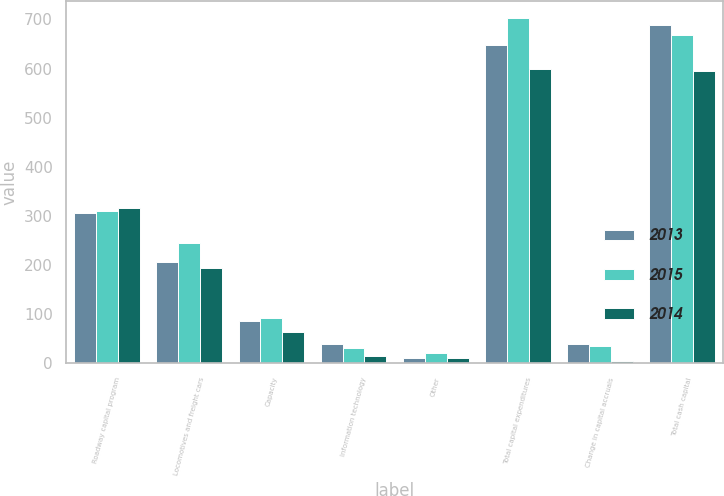<chart> <loc_0><loc_0><loc_500><loc_500><stacked_bar_chart><ecel><fcel>Roadway capital program<fcel>Locomotives and freight cars<fcel>Capacity<fcel>Information technology<fcel>Other<fcel>Total capital expenditures<fcel>Change in capital accruals<fcel>Total cash capital<nl><fcel>2013<fcel>306.2<fcel>205.9<fcel>86.6<fcel>39<fcel>11<fcel>648.7<fcel>39.3<fcel>688<nl><fcel>2015<fcel>311.1<fcel>245.1<fcel>93<fcel>31.9<fcel>21.6<fcel>702.7<fcel>34.5<fcel>668.2<nl><fcel>2014<fcel>315.7<fcel>194.7<fcel>63.1<fcel>15.6<fcel>10<fcel>599.1<fcel>4.3<fcel>594.8<nl></chart> 